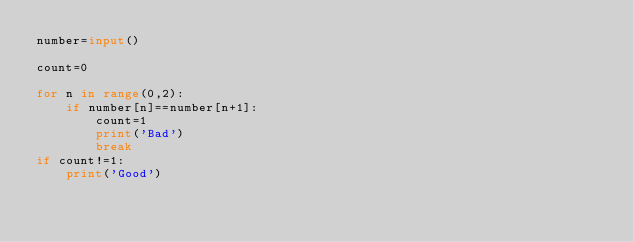Convert code to text. <code><loc_0><loc_0><loc_500><loc_500><_Python_>number=input()

count=0

for n in range(0,2):
    if number[n]==number[n+1]:
        count=1
        print('Bad')
        break
if count!=1:
    print('Good')</code> 